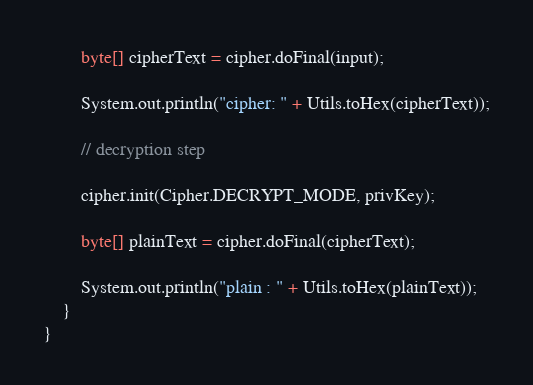<code> <loc_0><loc_0><loc_500><loc_500><_Java_>
        byte[] cipherText = cipher.doFinal(input);

        System.out.println("cipher: " + Utils.toHex(cipherText));
        
        // decryption step

        cipher.init(Cipher.DECRYPT_MODE, privKey);

        byte[] plainText = cipher.doFinal(cipherText);
        
        System.out.println("plain : " + Utils.toHex(plainText));
    }
}
</code> 